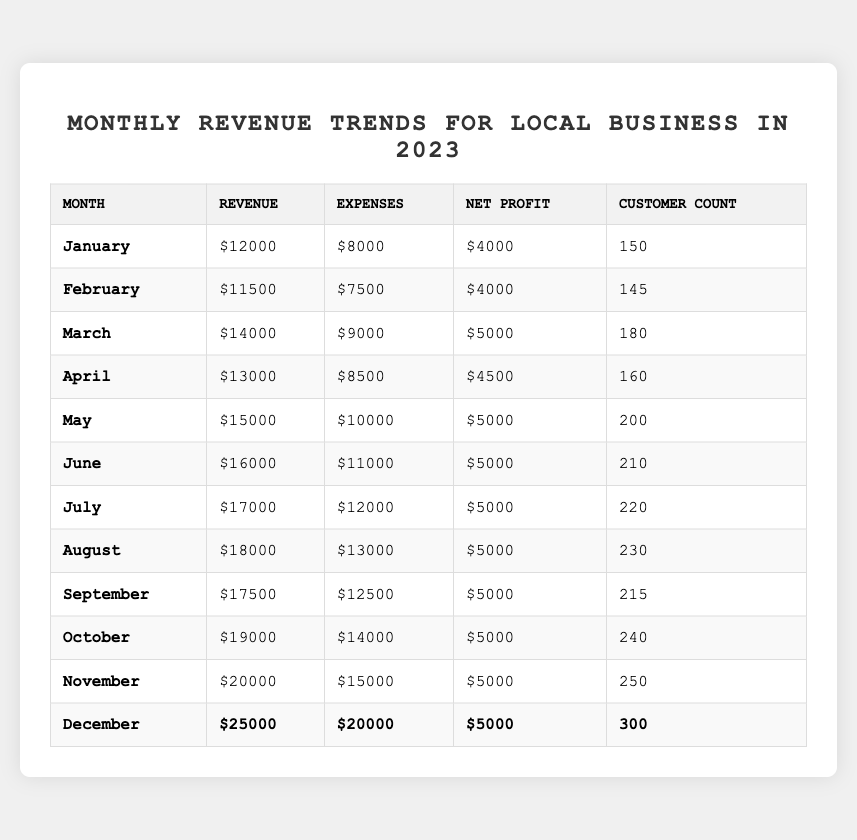What was the total revenue for the month of June? The table shows that the revenue for June is listed as 16,000.
Answer: 16,000 What is the average net profit from January to November? The net profits from January to November are 4,000 for January, February, 5,000 for March through November (9 months total). Adding them up: 4,000 + 4,000 + 5,000 * 9 = 4,000 + 36,000 = 40,000. There are 11 months total, so the average is 40,000 / 11 = 3,636.36 (rounded).
Answer: Approximately 3,636 Did the customer count exceed 200 in October? In October, the customer count is listed as 240, which exceeds 200.
Answer: Yes What was the month with the highest revenue, and what was that revenue? December had the highest revenue, which is 25,000, as seen in the last row of the table.
Answer: December, 25,000 What is the total increase in revenue from January to December? January's revenue is 12,000, and December's is 25,000. The increase is calculated as 25,000 - 12,000 = 13,000.
Answer: 13,000 In which month did we first see a customer count of over 200? The customer count first exceeded 200 in May, where it reached 200.
Answer: May How many months had a net profit of exactly 5,000? From the table, March, May, June, July, August, September, October, November, and December all had a net profit of 5,000, totaling 9 months.
Answer: 9 What was the change in expenses from February to December? February's expenses are 7,500 and December's are 20,000. The change is calculated as 20,000 - 7,500 = 12,500.
Answer: 12,500 Is it true that the revenue in November was higher than in October? November's revenue is 20,000, while October's is 19,000. Since 20,000 is greater than 19,000, the statement is true.
Answer: True What is the median revenue across all months? The revenues in ascending order are: 11,500, 12,000, 13,000, 14,000, 15,000, 16,000, 17,000, 18,000, 17,500, 19,000, 20,000, 25,000. The median is the average of the 6th and 7th values (16,000 and 17,000), so (16,000 + 17,000) / 2 = 16,500.
Answer: 16,500 